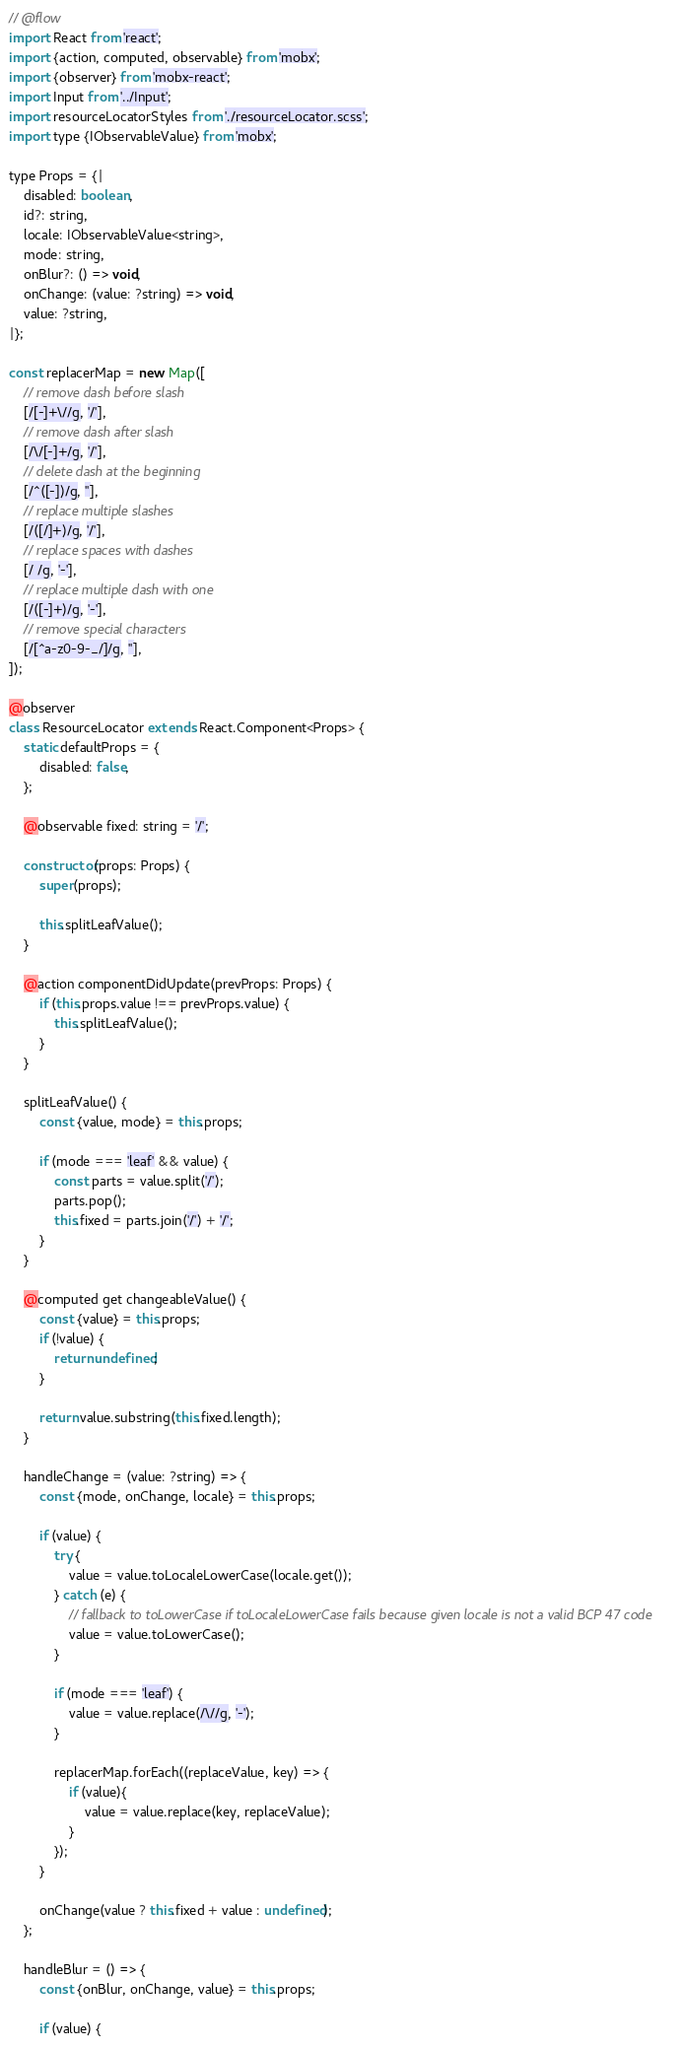Convert code to text. <code><loc_0><loc_0><loc_500><loc_500><_JavaScript_>// @flow
import React from 'react';
import {action, computed, observable} from 'mobx';
import {observer} from 'mobx-react';
import Input from '../Input';
import resourceLocatorStyles from './resourceLocator.scss';
import type {IObservableValue} from 'mobx';

type Props = {|
    disabled: boolean,
    id?: string,
    locale: IObservableValue<string>,
    mode: string,
    onBlur?: () => void,
    onChange: (value: ?string) => void,
    value: ?string,
|};

const replacerMap = new Map([
    // remove dash before slash
    [/[-]+\//g, '/'],
    // remove dash after slash
    [/\/[-]+/g, '/'],
    // delete dash at the beginning
    [/^([-])/g, ''],
    // replace multiple slashes
    [/([/]+)/g, '/'],
    // replace spaces with dashes
    [/ /g, '-'],
    // replace multiple dash with one
    [/([-]+)/g, '-'],
    // remove special characters
    [/[^a-z0-9-_/]/g, ''],
]);

@observer
class ResourceLocator extends React.Component<Props> {
    static defaultProps = {
        disabled: false,
    };

    @observable fixed: string = '/';

    constructor(props: Props) {
        super(props);

        this.splitLeafValue();
    }

    @action componentDidUpdate(prevProps: Props) {
        if (this.props.value !== prevProps.value) {
            this.splitLeafValue();
        }
    }

    splitLeafValue() {
        const {value, mode} = this.props;

        if (mode === 'leaf' && value) {
            const parts = value.split('/');
            parts.pop();
            this.fixed = parts.join('/') + '/';
        }
    }

    @computed get changeableValue() {
        const {value} = this.props;
        if (!value) {
            return undefined;
        }

        return value.substring(this.fixed.length);
    }

    handleChange = (value: ?string) => {
        const {mode, onChange, locale} = this.props;

        if (value) {
            try {
                value = value.toLocaleLowerCase(locale.get());
            } catch (e) {
                // fallback to toLowerCase if toLocaleLowerCase fails because given locale is not a valid BCP 47 code
                value = value.toLowerCase();
            }

            if (mode === 'leaf') {
                value = value.replace(/\//g, '-');
            }

            replacerMap.forEach((replaceValue, key) => {
                if (value){
                    value = value.replace(key, replaceValue);
                }
            });
        }

        onChange(value ? this.fixed + value : undefined);
    };

    handleBlur = () => {
        const {onBlur, onChange, value} = this.props;

        if (value) {</code> 